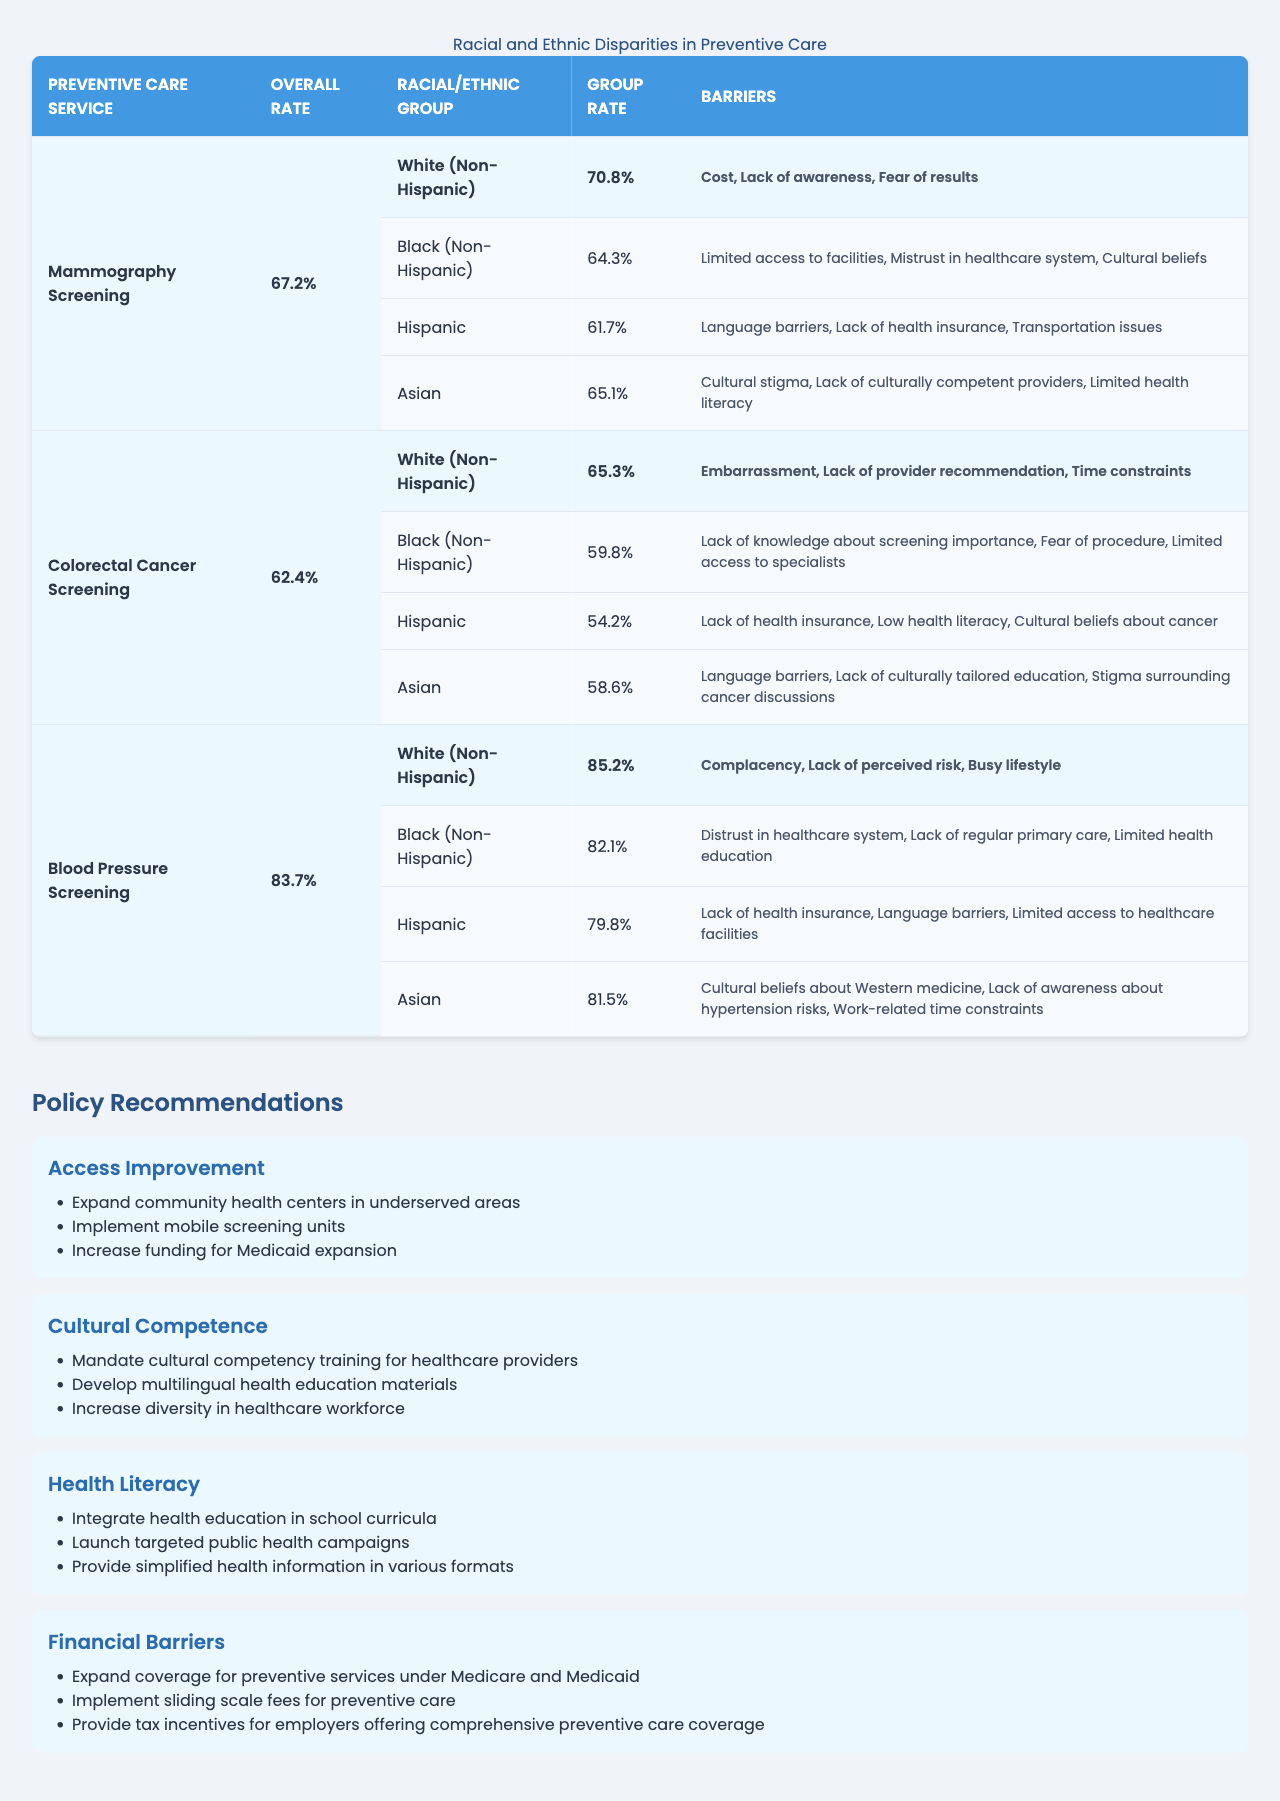What is the overall rate for Blood Pressure Screening? The overall rate for Blood Pressure Screening is specified in the table under the respective service type, which is listed as 83.7%.
Answer: 83.7% Which racial/ethnic group has the highest rate of Mammography Screening? By comparing the individual group rates under Mammography Screening, the highest rate is for White (Non-Hispanic) at 70.8%.
Answer: White (Non-Hispanic) What is the difference in the screening rate between Hispanic and Black (Non-Hispanic) groups for Colorectal Cancer Screening? To find the difference, subtract the Black (Non-Hispanic) rate of 59.8% from the Hispanic rate of 54.2%, resulting in a difference of 5.6%.
Answer: 5.6% Does the Asian group have a higher or lower rate of Blood Pressure Screening compared to the Overall Rate? The Asian group's rate is 81.5%, which is lower than the overall rate of 83.7%.
Answer: Lower What are the barriers to Mammography Screening for the Hispanic group? Under the barriers section for the Hispanic group, it lists language barriers, lack of health insurance, and transportation issues.
Answer: Language barriers, lack of health insurance, transportation issues What is the average rate of preventive care services among all racial/ethnic groups for the Mammography Screening? The average can be calculated by summing the individual rates for all groups (70.8% + 64.3% + 61.7% + 65.1%) = 261.9%, and dividing by 4, which gives an average of 65.475%.
Answer: 65.475% Which focus area has strategies to improve financial barriers? The focus area mentioning strategies to improve financial barriers is explicitly labeled in the policy recommendations section.
Answer: Financial Barriers List two barriers faced by Black (Non-Hispanic) individuals regarding Colorectal Cancer Screening. By identifying the barriers listed for Black (Non-Hispanic) from the table, the barriers mentioned include lack of knowledge about screening importance and fear of the procedure.
Answer: Lack of knowledge about screening importance, fear of procedure What is the total number of strategies presented for improving cultural competence? The table presents three strategies under the focus area of Cultural Competence, so the total is 3.
Answer: 3 Is it true that the Hispanic group has the lowest rate of Colorectal Cancer Screening? By comparing the rates for each group in Colorectal Cancer Screening, Hispanic has the lowest rate at 54.2% compared to others.
Answer: True 